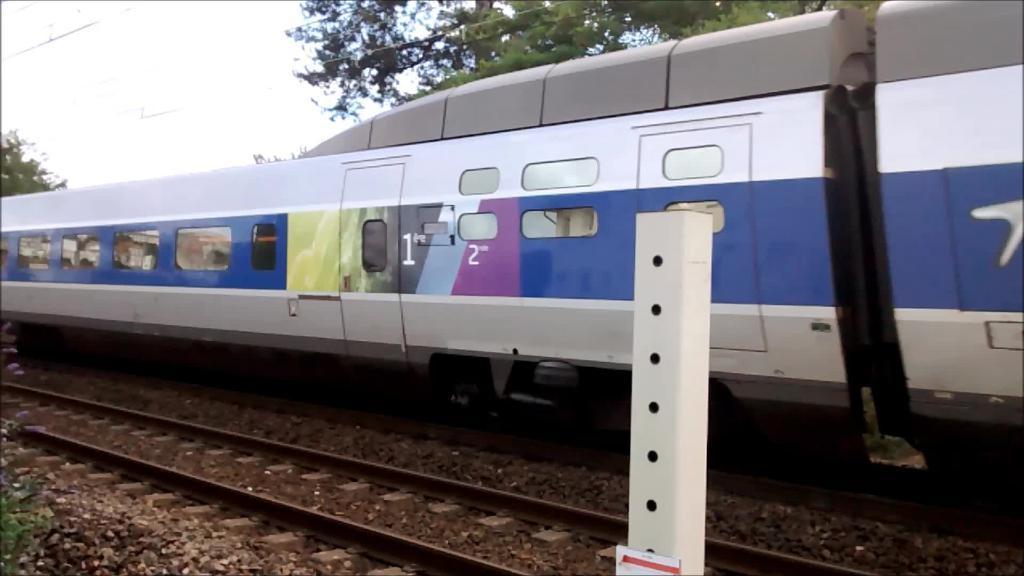Could you give a brief overview of what you see in this image? In the center of the image we can see a train on the track. In the background there are trees and sky. At the bottom there is a pole. 